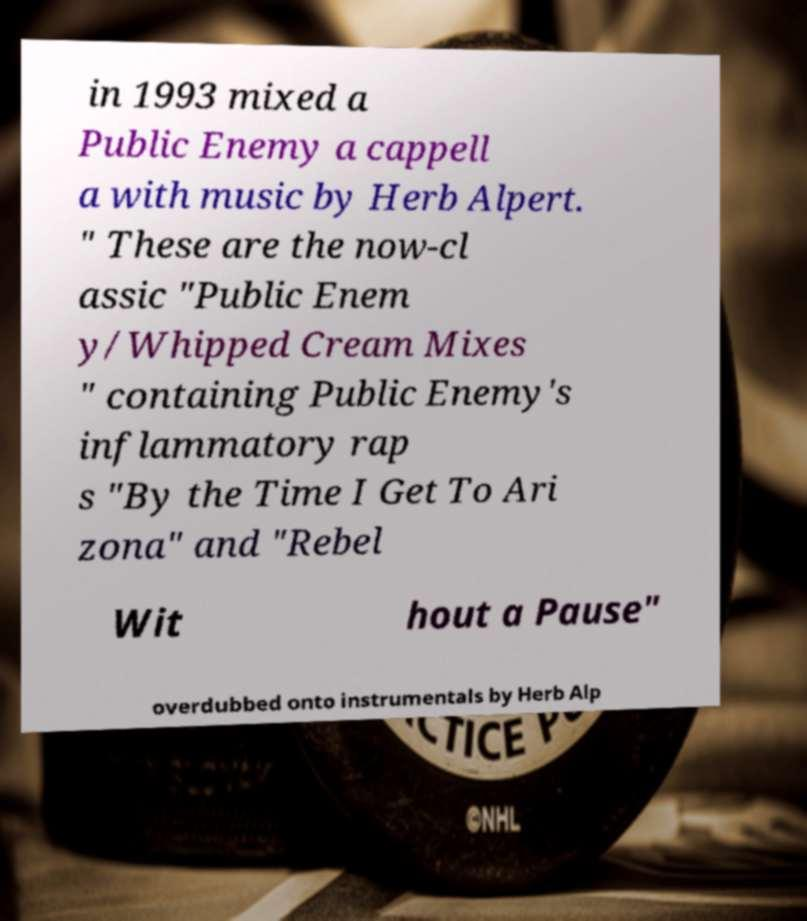Please identify and transcribe the text found in this image. in 1993 mixed a Public Enemy a cappell a with music by Herb Alpert. " These are the now-cl assic "Public Enem y/Whipped Cream Mixes " containing Public Enemy's inflammatory rap s "By the Time I Get To Ari zona" and "Rebel Wit hout a Pause" overdubbed onto instrumentals by Herb Alp 